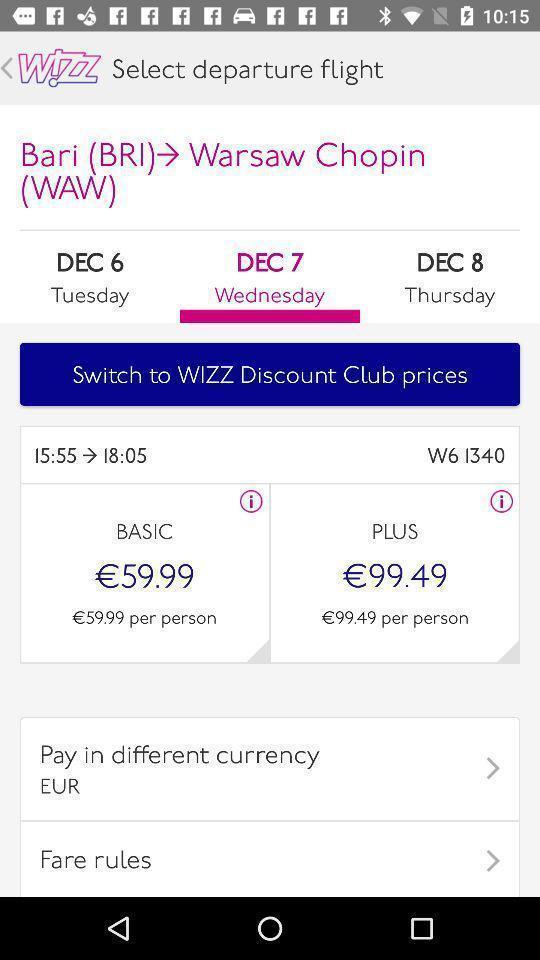Describe the visual elements of this screenshot. Selecting a departure flight from the given flight details. 